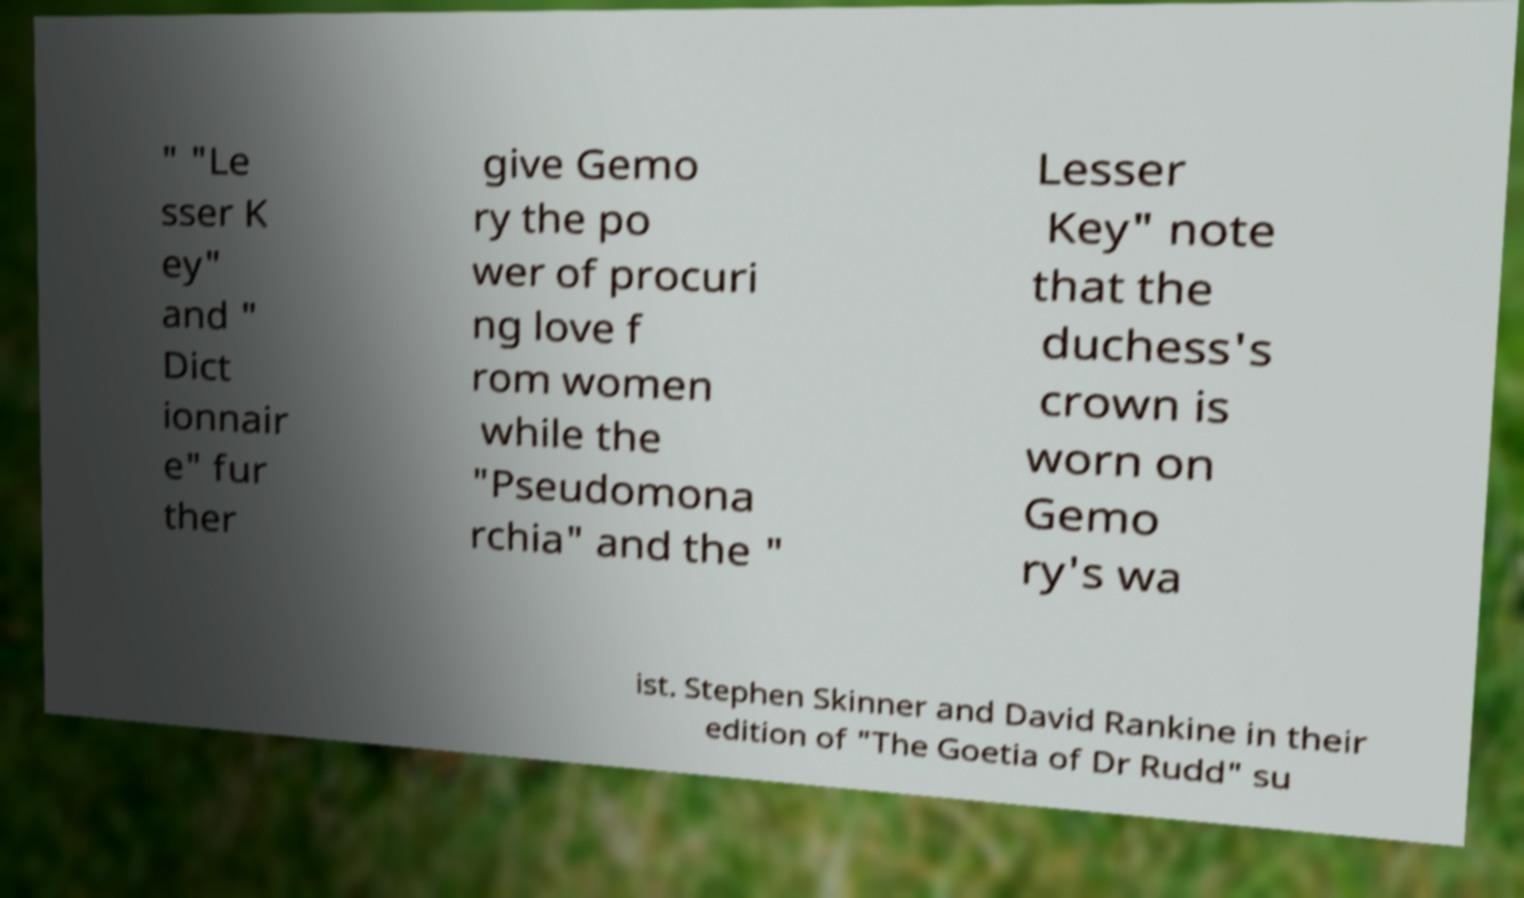There's text embedded in this image that I need extracted. Can you transcribe it verbatim? " "Le sser K ey" and " Dict ionnair e" fur ther give Gemo ry the po wer of procuri ng love f rom women while the "Pseudomona rchia" and the " Lesser Key" note that the duchess's crown is worn on Gemo ry's wa ist. Stephen Skinner and David Rankine in their edition of "The Goetia of Dr Rudd" su 